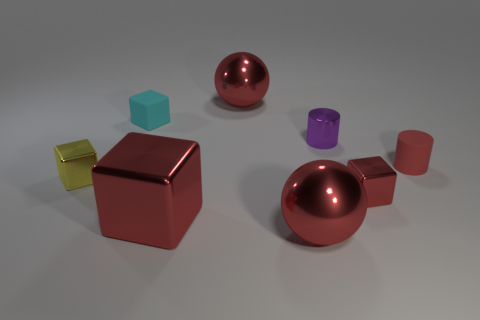Subtract all tiny red metal blocks. How many blocks are left? 3 Subtract all purple cylinders. How many cylinders are left? 1 Subtract all purple balls. How many red blocks are left? 2 Subtract 1 cylinders. How many cylinders are left? 1 Add 2 small purple objects. How many objects exist? 10 Subtract all cylinders. How many objects are left? 6 Subtract 1 red cylinders. How many objects are left? 7 Subtract all cyan blocks. Subtract all cyan balls. How many blocks are left? 3 Subtract all tiny cyan rubber blocks. Subtract all tiny cyan blocks. How many objects are left? 6 Add 8 rubber things. How many rubber things are left? 10 